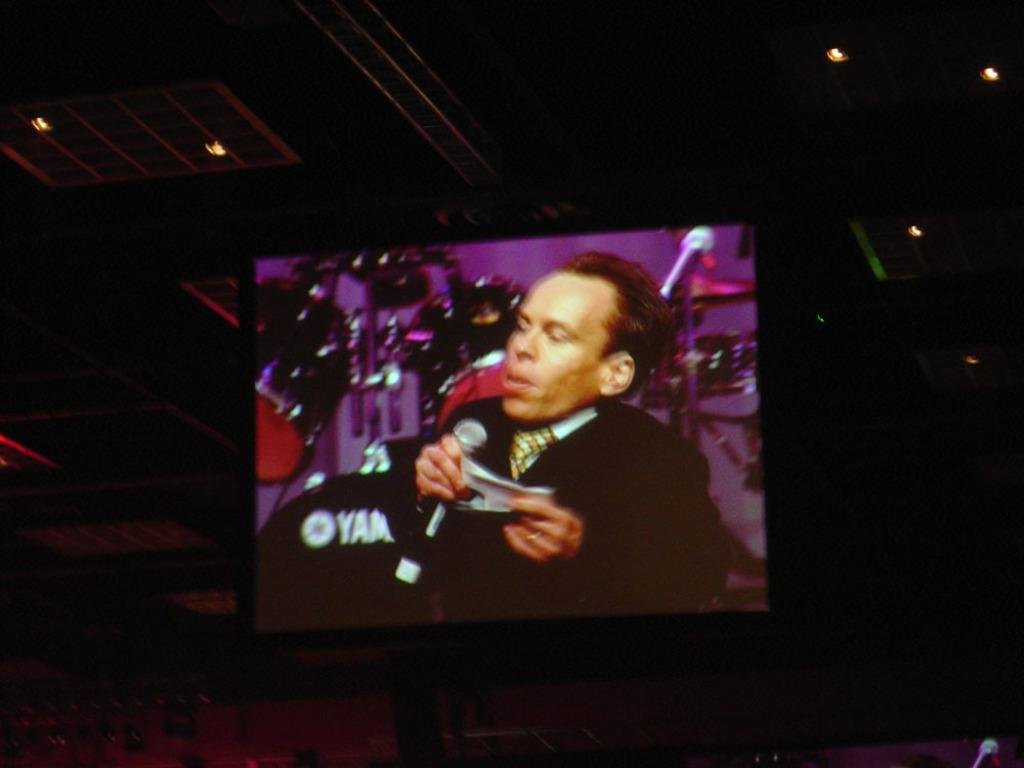What is the main feature of the image? There is a projected screen in the image. Can you describe any other elements in the image? Lights are visible at the top of the image. How many hands are visible on the projected screen in the image? There are no hands visible on the projected screen in the image. What type of faucet can be seen in the image? There is no faucet present in the image. 